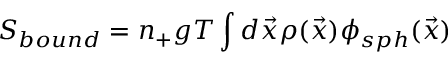Convert formula to latex. <formula><loc_0><loc_0><loc_500><loc_500>S _ { b o u n d } = n _ { + } g T \int d { \vec { x } } \rho ( { \vec { x } } ) \phi _ { s p h } ( { \vec { x } } )</formula> 